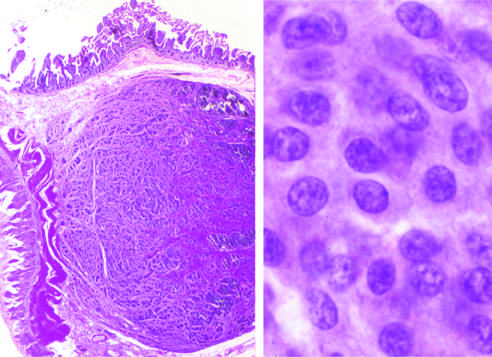do carcinoid tumors form a submucosal nodule composed of tumor cells embedded in dense fibrous tissue?
Answer the question using a single word or phrase. Yes 